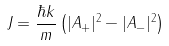Convert formula to latex. <formula><loc_0><loc_0><loc_500><loc_500>J = \frac { \hbar { k } } { m } \left ( | A _ { + } | ^ { 2 } - | A _ { - } | ^ { 2 } \right )</formula> 